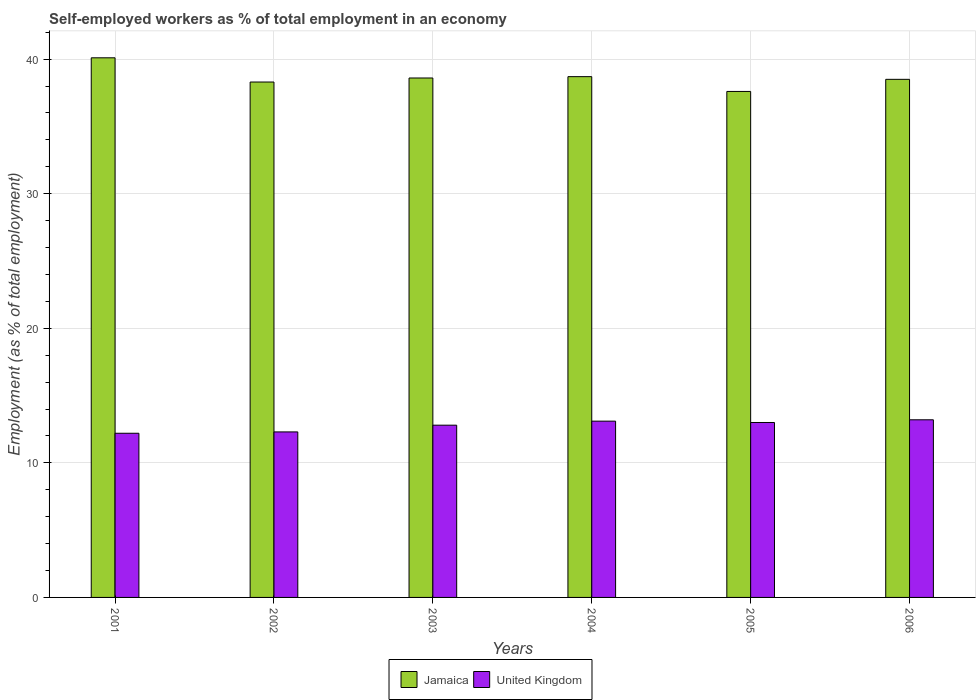How many groups of bars are there?
Offer a terse response. 6. Are the number of bars per tick equal to the number of legend labels?
Offer a terse response. Yes. Are the number of bars on each tick of the X-axis equal?
Make the answer very short. Yes. How many bars are there on the 5th tick from the right?
Give a very brief answer. 2. What is the label of the 6th group of bars from the left?
Your answer should be very brief. 2006. In how many cases, is the number of bars for a given year not equal to the number of legend labels?
Provide a succinct answer. 0. What is the percentage of self-employed workers in Jamaica in 2003?
Provide a short and direct response. 38.6. Across all years, what is the maximum percentage of self-employed workers in Jamaica?
Keep it short and to the point. 40.1. Across all years, what is the minimum percentage of self-employed workers in United Kingdom?
Provide a short and direct response. 12.2. What is the total percentage of self-employed workers in Jamaica in the graph?
Provide a succinct answer. 231.8. What is the difference between the percentage of self-employed workers in Jamaica in 2003 and that in 2004?
Offer a terse response. -0.1. What is the difference between the percentage of self-employed workers in Jamaica in 2003 and the percentage of self-employed workers in United Kingdom in 2006?
Provide a succinct answer. 25.4. What is the average percentage of self-employed workers in Jamaica per year?
Your answer should be very brief. 38.63. In the year 2005, what is the difference between the percentage of self-employed workers in United Kingdom and percentage of self-employed workers in Jamaica?
Make the answer very short. -24.6. In how many years, is the percentage of self-employed workers in United Kingdom greater than 28 %?
Your response must be concise. 0. What is the ratio of the percentage of self-employed workers in Jamaica in 2004 to that in 2006?
Keep it short and to the point. 1.01. Is the percentage of self-employed workers in United Kingdom in 2003 less than that in 2006?
Offer a terse response. Yes. What is the difference between the highest and the second highest percentage of self-employed workers in United Kingdom?
Your answer should be very brief. 0.1. What is the difference between the highest and the lowest percentage of self-employed workers in Jamaica?
Give a very brief answer. 2.5. Is the sum of the percentage of self-employed workers in United Kingdom in 2003 and 2006 greater than the maximum percentage of self-employed workers in Jamaica across all years?
Make the answer very short. No. What does the 1st bar from the right in 2002 represents?
Give a very brief answer. United Kingdom. How many years are there in the graph?
Your answer should be very brief. 6. Are the values on the major ticks of Y-axis written in scientific E-notation?
Give a very brief answer. No. Does the graph contain any zero values?
Your answer should be compact. No. Where does the legend appear in the graph?
Make the answer very short. Bottom center. How many legend labels are there?
Your answer should be very brief. 2. What is the title of the graph?
Offer a very short reply. Self-employed workers as % of total employment in an economy. What is the label or title of the X-axis?
Offer a very short reply. Years. What is the label or title of the Y-axis?
Your response must be concise. Employment (as % of total employment). What is the Employment (as % of total employment) in Jamaica in 2001?
Offer a terse response. 40.1. What is the Employment (as % of total employment) in United Kingdom in 2001?
Your response must be concise. 12.2. What is the Employment (as % of total employment) of Jamaica in 2002?
Your response must be concise. 38.3. What is the Employment (as % of total employment) in United Kingdom in 2002?
Your response must be concise. 12.3. What is the Employment (as % of total employment) in Jamaica in 2003?
Make the answer very short. 38.6. What is the Employment (as % of total employment) of United Kingdom in 2003?
Give a very brief answer. 12.8. What is the Employment (as % of total employment) of Jamaica in 2004?
Offer a terse response. 38.7. What is the Employment (as % of total employment) in United Kingdom in 2004?
Give a very brief answer. 13.1. What is the Employment (as % of total employment) of Jamaica in 2005?
Provide a succinct answer. 37.6. What is the Employment (as % of total employment) of United Kingdom in 2005?
Make the answer very short. 13. What is the Employment (as % of total employment) of Jamaica in 2006?
Provide a short and direct response. 38.5. What is the Employment (as % of total employment) of United Kingdom in 2006?
Your answer should be compact. 13.2. Across all years, what is the maximum Employment (as % of total employment) in Jamaica?
Your response must be concise. 40.1. Across all years, what is the maximum Employment (as % of total employment) of United Kingdom?
Provide a succinct answer. 13.2. Across all years, what is the minimum Employment (as % of total employment) of Jamaica?
Ensure brevity in your answer.  37.6. Across all years, what is the minimum Employment (as % of total employment) of United Kingdom?
Offer a very short reply. 12.2. What is the total Employment (as % of total employment) in Jamaica in the graph?
Your answer should be very brief. 231.8. What is the total Employment (as % of total employment) in United Kingdom in the graph?
Provide a short and direct response. 76.6. What is the difference between the Employment (as % of total employment) in Jamaica in 2001 and that in 2002?
Offer a terse response. 1.8. What is the difference between the Employment (as % of total employment) of Jamaica in 2001 and that in 2003?
Provide a short and direct response. 1.5. What is the difference between the Employment (as % of total employment) in United Kingdom in 2001 and that in 2003?
Provide a short and direct response. -0.6. What is the difference between the Employment (as % of total employment) of Jamaica in 2001 and that in 2005?
Your response must be concise. 2.5. What is the difference between the Employment (as % of total employment) of United Kingdom in 2001 and that in 2006?
Offer a terse response. -1. What is the difference between the Employment (as % of total employment) in Jamaica in 2002 and that in 2003?
Your answer should be very brief. -0.3. What is the difference between the Employment (as % of total employment) of Jamaica in 2002 and that in 2004?
Provide a short and direct response. -0.4. What is the difference between the Employment (as % of total employment) of Jamaica in 2002 and that in 2005?
Your response must be concise. 0.7. What is the difference between the Employment (as % of total employment) in United Kingdom in 2002 and that in 2005?
Ensure brevity in your answer.  -0.7. What is the difference between the Employment (as % of total employment) in United Kingdom in 2002 and that in 2006?
Your answer should be compact. -0.9. What is the difference between the Employment (as % of total employment) of Jamaica in 2003 and that in 2005?
Offer a terse response. 1. What is the difference between the Employment (as % of total employment) in United Kingdom in 2004 and that in 2006?
Your response must be concise. -0.1. What is the difference between the Employment (as % of total employment) in Jamaica in 2001 and the Employment (as % of total employment) in United Kingdom in 2002?
Make the answer very short. 27.8. What is the difference between the Employment (as % of total employment) in Jamaica in 2001 and the Employment (as % of total employment) in United Kingdom in 2003?
Keep it short and to the point. 27.3. What is the difference between the Employment (as % of total employment) of Jamaica in 2001 and the Employment (as % of total employment) of United Kingdom in 2005?
Make the answer very short. 27.1. What is the difference between the Employment (as % of total employment) of Jamaica in 2001 and the Employment (as % of total employment) of United Kingdom in 2006?
Provide a succinct answer. 26.9. What is the difference between the Employment (as % of total employment) of Jamaica in 2002 and the Employment (as % of total employment) of United Kingdom in 2004?
Offer a terse response. 25.2. What is the difference between the Employment (as % of total employment) of Jamaica in 2002 and the Employment (as % of total employment) of United Kingdom in 2005?
Ensure brevity in your answer.  25.3. What is the difference between the Employment (as % of total employment) in Jamaica in 2002 and the Employment (as % of total employment) in United Kingdom in 2006?
Give a very brief answer. 25.1. What is the difference between the Employment (as % of total employment) of Jamaica in 2003 and the Employment (as % of total employment) of United Kingdom in 2005?
Give a very brief answer. 25.6. What is the difference between the Employment (as % of total employment) in Jamaica in 2003 and the Employment (as % of total employment) in United Kingdom in 2006?
Ensure brevity in your answer.  25.4. What is the difference between the Employment (as % of total employment) in Jamaica in 2004 and the Employment (as % of total employment) in United Kingdom in 2005?
Your answer should be very brief. 25.7. What is the difference between the Employment (as % of total employment) in Jamaica in 2005 and the Employment (as % of total employment) in United Kingdom in 2006?
Ensure brevity in your answer.  24.4. What is the average Employment (as % of total employment) in Jamaica per year?
Your response must be concise. 38.63. What is the average Employment (as % of total employment) in United Kingdom per year?
Ensure brevity in your answer.  12.77. In the year 2001, what is the difference between the Employment (as % of total employment) of Jamaica and Employment (as % of total employment) of United Kingdom?
Make the answer very short. 27.9. In the year 2002, what is the difference between the Employment (as % of total employment) of Jamaica and Employment (as % of total employment) of United Kingdom?
Offer a terse response. 26. In the year 2003, what is the difference between the Employment (as % of total employment) in Jamaica and Employment (as % of total employment) in United Kingdom?
Provide a succinct answer. 25.8. In the year 2004, what is the difference between the Employment (as % of total employment) in Jamaica and Employment (as % of total employment) in United Kingdom?
Your answer should be very brief. 25.6. In the year 2005, what is the difference between the Employment (as % of total employment) in Jamaica and Employment (as % of total employment) in United Kingdom?
Offer a terse response. 24.6. In the year 2006, what is the difference between the Employment (as % of total employment) of Jamaica and Employment (as % of total employment) of United Kingdom?
Give a very brief answer. 25.3. What is the ratio of the Employment (as % of total employment) in Jamaica in 2001 to that in 2002?
Give a very brief answer. 1.05. What is the ratio of the Employment (as % of total employment) in Jamaica in 2001 to that in 2003?
Provide a succinct answer. 1.04. What is the ratio of the Employment (as % of total employment) of United Kingdom in 2001 to that in 2003?
Your answer should be compact. 0.95. What is the ratio of the Employment (as % of total employment) in Jamaica in 2001 to that in 2004?
Your response must be concise. 1.04. What is the ratio of the Employment (as % of total employment) of United Kingdom in 2001 to that in 2004?
Offer a terse response. 0.93. What is the ratio of the Employment (as % of total employment) in Jamaica in 2001 to that in 2005?
Ensure brevity in your answer.  1.07. What is the ratio of the Employment (as % of total employment) of United Kingdom in 2001 to that in 2005?
Offer a very short reply. 0.94. What is the ratio of the Employment (as % of total employment) in Jamaica in 2001 to that in 2006?
Offer a terse response. 1.04. What is the ratio of the Employment (as % of total employment) in United Kingdom in 2001 to that in 2006?
Your answer should be compact. 0.92. What is the ratio of the Employment (as % of total employment) in United Kingdom in 2002 to that in 2003?
Offer a very short reply. 0.96. What is the ratio of the Employment (as % of total employment) of United Kingdom in 2002 to that in 2004?
Provide a short and direct response. 0.94. What is the ratio of the Employment (as % of total employment) in Jamaica in 2002 to that in 2005?
Your response must be concise. 1.02. What is the ratio of the Employment (as % of total employment) in United Kingdom in 2002 to that in 2005?
Provide a short and direct response. 0.95. What is the ratio of the Employment (as % of total employment) of Jamaica in 2002 to that in 2006?
Offer a terse response. 0.99. What is the ratio of the Employment (as % of total employment) in United Kingdom in 2002 to that in 2006?
Provide a short and direct response. 0.93. What is the ratio of the Employment (as % of total employment) of Jamaica in 2003 to that in 2004?
Offer a very short reply. 1. What is the ratio of the Employment (as % of total employment) in United Kingdom in 2003 to that in 2004?
Provide a short and direct response. 0.98. What is the ratio of the Employment (as % of total employment) of Jamaica in 2003 to that in 2005?
Keep it short and to the point. 1.03. What is the ratio of the Employment (as % of total employment) of United Kingdom in 2003 to that in 2005?
Your answer should be very brief. 0.98. What is the ratio of the Employment (as % of total employment) of Jamaica in 2003 to that in 2006?
Keep it short and to the point. 1. What is the ratio of the Employment (as % of total employment) in United Kingdom in 2003 to that in 2006?
Offer a terse response. 0.97. What is the ratio of the Employment (as % of total employment) in Jamaica in 2004 to that in 2005?
Your answer should be compact. 1.03. What is the ratio of the Employment (as % of total employment) of United Kingdom in 2004 to that in 2005?
Offer a terse response. 1.01. What is the ratio of the Employment (as % of total employment) of Jamaica in 2004 to that in 2006?
Offer a very short reply. 1.01. What is the ratio of the Employment (as % of total employment) of Jamaica in 2005 to that in 2006?
Your answer should be very brief. 0.98. What is the difference between the highest and the second highest Employment (as % of total employment) of Jamaica?
Give a very brief answer. 1.4. What is the difference between the highest and the second highest Employment (as % of total employment) of United Kingdom?
Your answer should be compact. 0.1. 